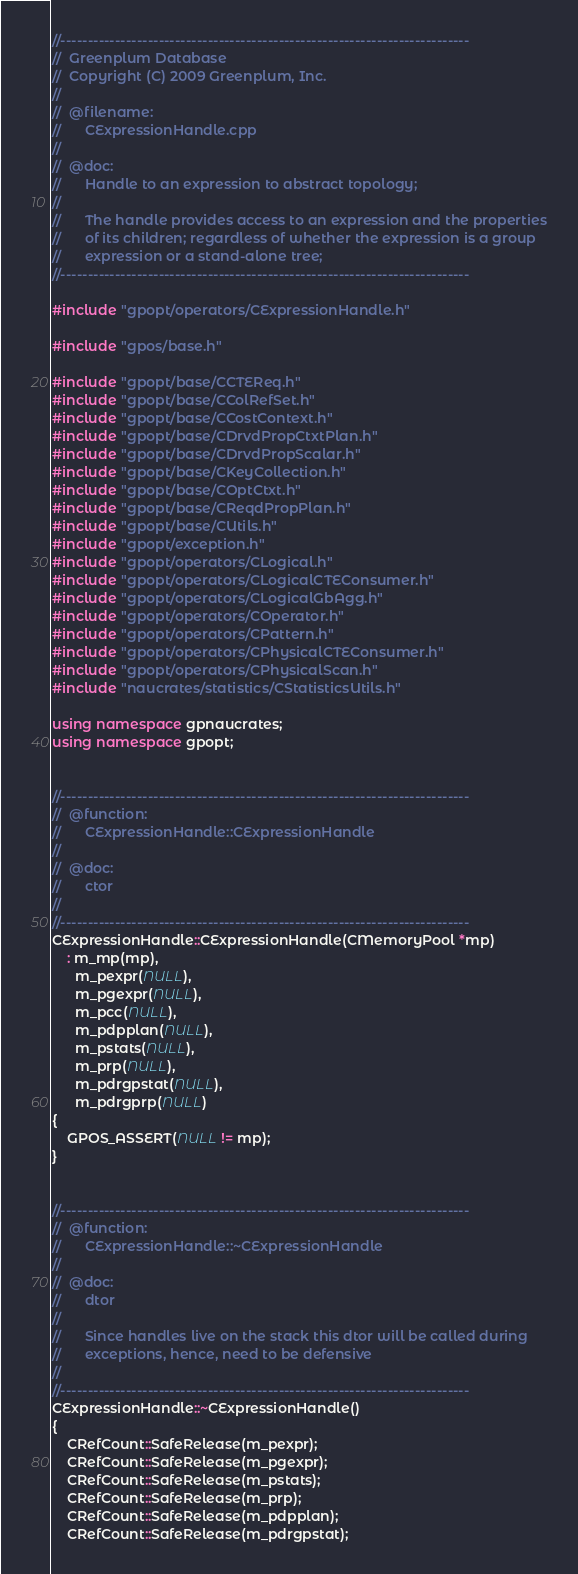Convert code to text. <code><loc_0><loc_0><loc_500><loc_500><_C++_>//---------------------------------------------------------------------------
//	Greenplum Database
//	Copyright (C) 2009 Greenplum, Inc.
//
//	@filename:
//		CExpressionHandle.cpp
//
//	@doc:
//		Handle to an expression to abstract topology;
//
//		The handle provides access to an expression and the properties
//		of its children; regardless of whether the expression is a group
//		expression or a stand-alone tree;
//---------------------------------------------------------------------------

#include "gpopt/operators/CExpressionHandle.h"

#include "gpos/base.h"

#include "gpopt/base/CCTEReq.h"
#include "gpopt/base/CColRefSet.h"
#include "gpopt/base/CCostContext.h"
#include "gpopt/base/CDrvdPropCtxtPlan.h"
#include "gpopt/base/CDrvdPropScalar.h"
#include "gpopt/base/CKeyCollection.h"
#include "gpopt/base/COptCtxt.h"
#include "gpopt/base/CReqdPropPlan.h"
#include "gpopt/base/CUtils.h"
#include "gpopt/exception.h"
#include "gpopt/operators/CLogical.h"
#include "gpopt/operators/CLogicalCTEConsumer.h"
#include "gpopt/operators/CLogicalGbAgg.h"
#include "gpopt/operators/COperator.h"
#include "gpopt/operators/CPattern.h"
#include "gpopt/operators/CPhysicalCTEConsumer.h"
#include "gpopt/operators/CPhysicalScan.h"
#include "naucrates/statistics/CStatisticsUtils.h"

using namespace gpnaucrates;
using namespace gpopt;


//---------------------------------------------------------------------------
//	@function:
//		CExpressionHandle::CExpressionHandle
//
//	@doc:
//		ctor
//
//---------------------------------------------------------------------------
CExpressionHandle::CExpressionHandle(CMemoryPool *mp)
	: m_mp(mp),
	  m_pexpr(NULL),
	  m_pgexpr(NULL),
	  m_pcc(NULL),
	  m_pdpplan(NULL),
	  m_pstats(NULL),
	  m_prp(NULL),
	  m_pdrgpstat(NULL),
	  m_pdrgprp(NULL)
{
	GPOS_ASSERT(NULL != mp);
}


//---------------------------------------------------------------------------
//	@function:
//		CExpressionHandle::~CExpressionHandle
//
//	@doc:
//		dtor
//
//		Since handles live on the stack this dtor will be called during
//		exceptions, hence, need to be defensive
//
//---------------------------------------------------------------------------
CExpressionHandle::~CExpressionHandle()
{
	CRefCount::SafeRelease(m_pexpr);
	CRefCount::SafeRelease(m_pgexpr);
	CRefCount::SafeRelease(m_pstats);
	CRefCount::SafeRelease(m_prp);
	CRefCount::SafeRelease(m_pdpplan);
	CRefCount::SafeRelease(m_pdrgpstat);</code> 